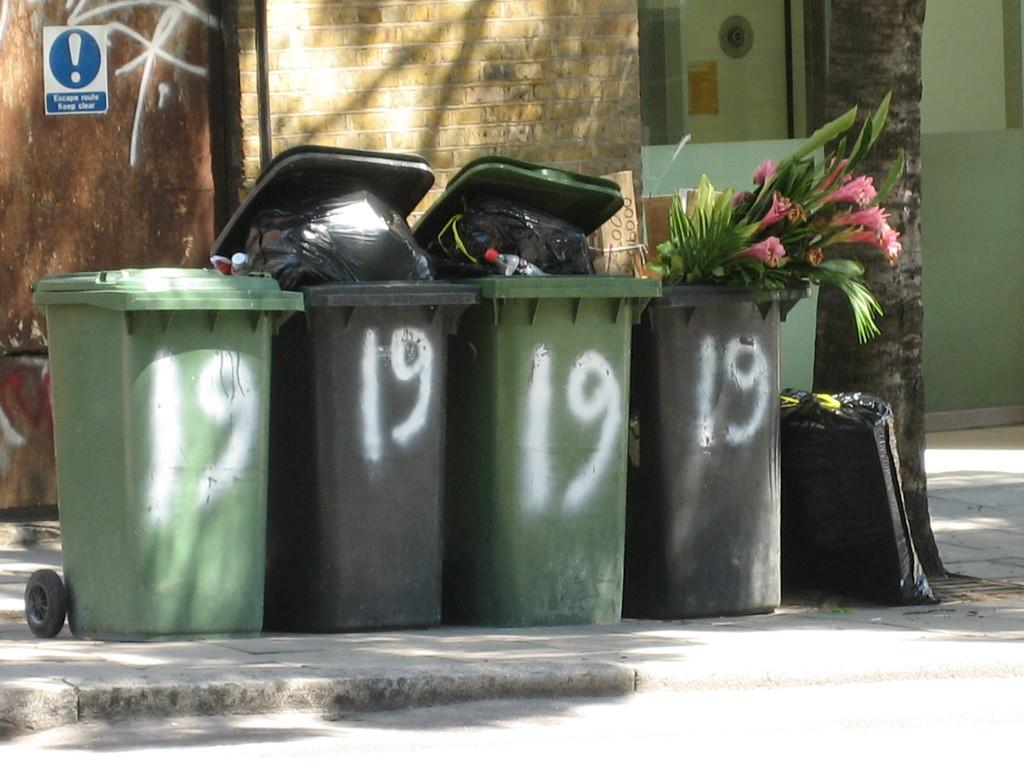<image>
Describe the image concisely. Four trash bins with the number 19 spray painted on them are lined up on the curb. 